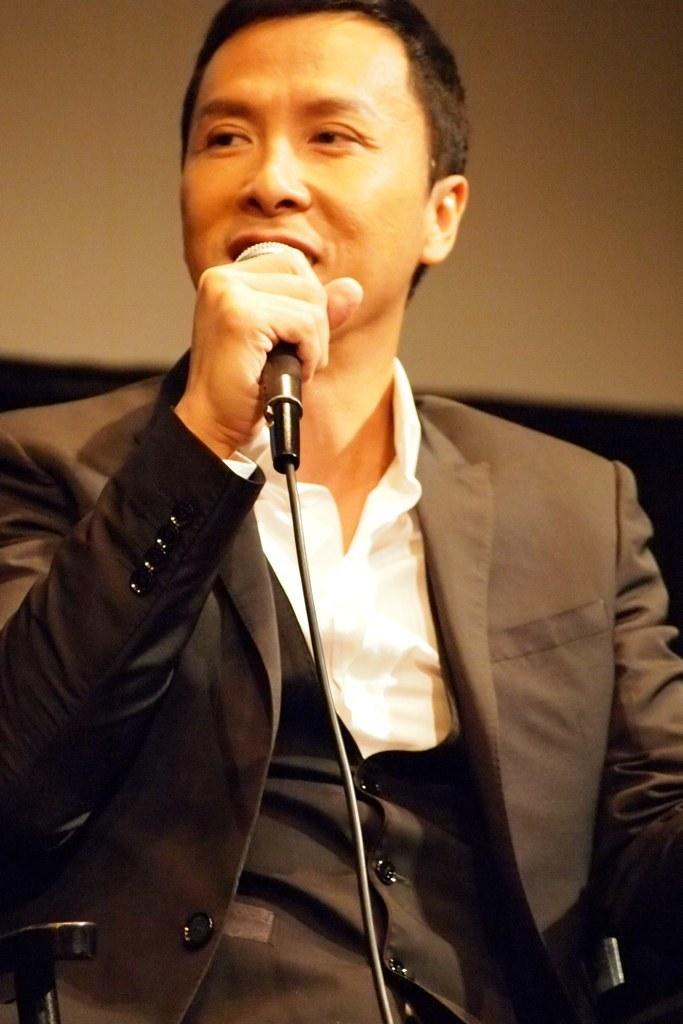Could you give a brief overview of what you see in this image? In this picture i could see a person wearing a formal blazer, vest and white shirt. He is holding a mic in his hand and talking to some one. In the background there is a yellow colored wall. 